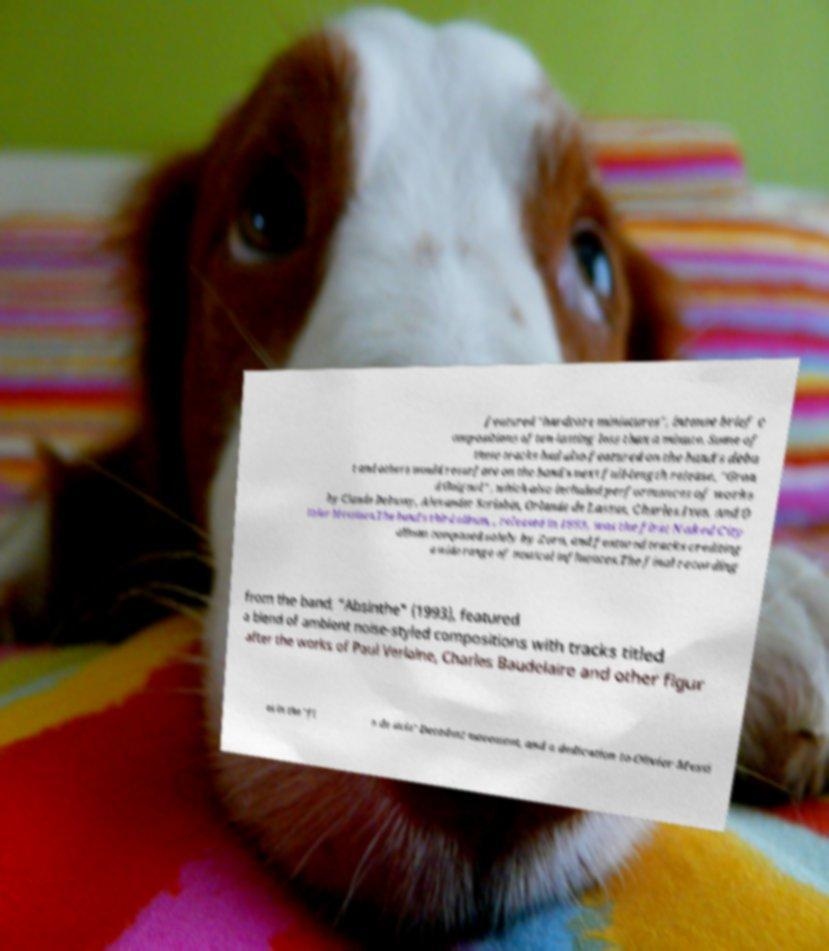What messages or text are displayed in this image? I need them in a readable, typed format. featured "hardcore miniatures", intense brief c ompositions often lasting less than a minute. Some of these tracks had also featured on the band's debu t and others would resurface on the band's next full-length release, "Gran d Guignol" , which also included performances of works by Claude Debussy, Alexander Scriabin, Orlande de Lassus, Charles Ives, and O livier Messiaen.The band's third album, , released in 1993, was the first Naked City album composed solely by Zorn, and featured tracks crediting a wide range of musical influences.The final recording from the band, "Absinthe" (1993), featured a blend of ambient noise-styled compositions with tracks titled after the works of Paul Verlaine, Charles Baudelaire and other figur es in the "fi n de sicle" Decadent movement, and a dedication to Olivier Messi 